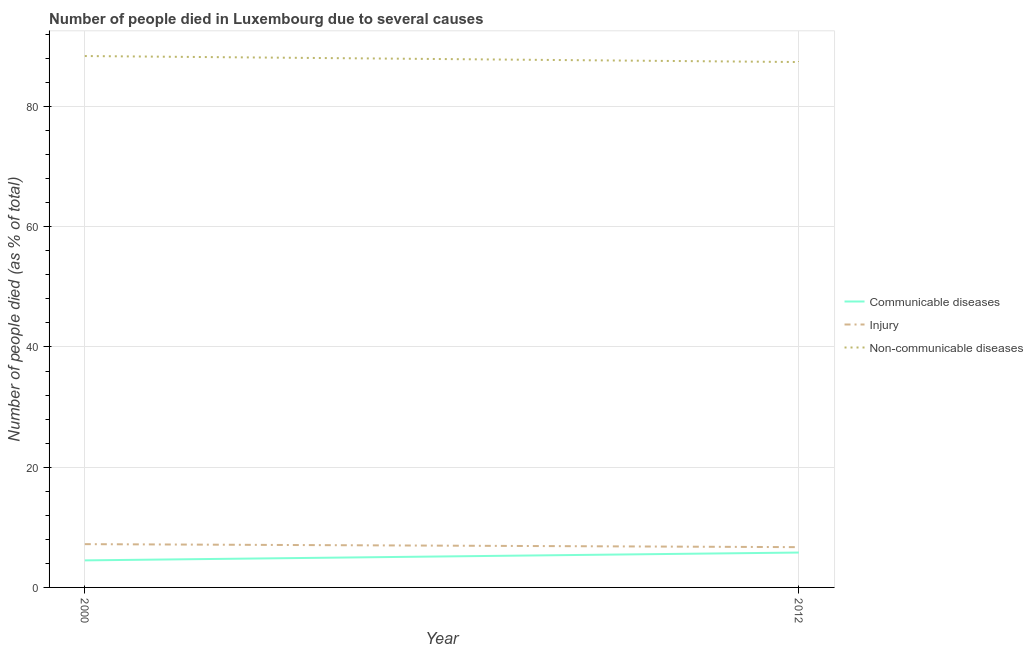Does the line corresponding to number of people who died of injury intersect with the line corresponding to number of people who dies of non-communicable diseases?
Give a very brief answer. No. What is the number of people who dies of non-communicable diseases in 2012?
Your answer should be compact. 87.4. Across all years, what is the maximum number of people who dies of non-communicable diseases?
Your answer should be very brief. 88.4. In which year was the number of people who died of injury minimum?
Ensure brevity in your answer.  2012. What is the total number of people who dies of non-communicable diseases in the graph?
Ensure brevity in your answer.  175.8. What is the difference between the number of people who died of communicable diseases in 2000 and that in 2012?
Your response must be concise. -1.3. What is the difference between the number of people who died of communicable diseases in 2012 and the number of people who dies of non-communicable diseases in 2000?
Give a very brief answer. -82.6. What is the average number of people who dies of non-communicable diseases per year?
Your response must be concise. 87.9. In the year 2000, what is the difference between the number of people who dies of non-communicable diseases and number of people who died of injury?
Keep it short and to the point. 81.2. In how many years, is the number of people who died of communicable diseases greater than 80 %?
Ensure brevity in your answer.  0. What is the ratio of the number of people who dies of non-communicable diseases in 2000 to that in 2012?
Your response must be concise. 1.01. Is the number of people who died of injury in 2000 less than that in 2012?
Make the answer very short. No. Is it the case that in every year, the sum of the number of people who died of communicable diseases and number of people who died of injury is greater than the number of people who dies of non-communicable diseases?
Give a very brief answer. No. Does the number of people who dies of non-communicable diseases monotonically increase over the years?
Your response must be concise. No. Is the number of people who dies of non-communicable diseases strictly greater than the number of people who died of injury over the years?
Make the answer very short. Yes. How many lines are there?
Keep it short and to the point. 3. Where does the legend appear in the graph?
Provide a succinct answer. Center right. How many legend labels are there?
Offer a very short reply. 3. How are the legend labels stacked?
Your answer should be compact. Vertical. What is the title of the graph?
Your answer should be very brief. Number of people died in Luxembourg due to several causes. What is the label or title of the Y-axis?
Offer a very short reply. Number of people died (as % of total). What is the Number of people died (as % of total) in Non-communicable diseases in 2000?
Offer a terse response. 88.4. What is the Number of people died (as % of total) of Injury in 2012?
Make the answer very short. 6.7. What is the Number of people died (as % of total) in Non-communicable diseases in 2012?
Offer a terse response. 87.4. Across all years, what is the maximum Number of people died (as % of total) in Injury?
Provide a short and direct response. 7.2. Across all years, what is the maximum Number of people died (as % of total) in Non-communicable diseases?
Offer a terse response. 88.4. Across all years, what is the minimum Number of people died (as % of total) of Injury?
Give a very brief answer. 6.7. Across all years, what is the minimum Number of people died (as % of total) of Non-communicable diseases?
Ensure brevity in your answer.  87.4. What is the total Number of people died (as % of total) of Communicable diseases in the graph?
Make the answer very short. 10.3. What is the total Number of people died (as % of total) of Non-communicable diseases in the graph?
Offer a terse response. 175.8. What is the difference between the Number of people died (as % of total) of Communicable diseases in 2000 and that in 2012?
Give a very brief answer. -1.3. What is the difference between the Number of people died (as % of total) of Communicable diseases in 2000 and the Number of people died (as % of total) of Injury in 2012?
Your response must be concise. -2.2. What is the difference between the Number of people died (as % of total) of Communicable diseases in 2000 and the Number of people died (as % of total) of Non-communicable diseases in 2012?
Keep it short and to the point. -82.9. What is the difference between the Number of people died (as % of total) of Injury in 2000 and the Number of people died (as % of total) of Non-communicable diseases in 2012?
Ensure brevity in your answer.  -80.2. What is the average Number of people died (as % of total) of Communicable diseases per year?
Provide a succinct answer. 5.15. What is the average Number of people died (as % of total) in Injury per year?
Keep it short and to the point. 6.95. What is the average Number of people died (as % of total) of Non-communicable diseases per year?
Your answer should be very brief. 87.9. In the year 2000, what is the difference between the Number of people died (as % of total) of Communicable diseases and Number of people died (as % of total) of Injury?
Offer a very short reply. -2.7. In the year 2000, what is the difference between the Number of people died (as % of total) of Communicable diseases and Number of people died (as % of total) of Non-communicable diseases?
Give a very brief answer. -83.9. In the year 2000, what is the difference between the Number of people died (as % of total) in Injury and Number of people died (as % of total) in Non-communicable diseases?
Keep it short and to the point. -81.2. In the year 2012, what is the difference between the Number of people died (as % of total) in Communicable diseases and Number of people died (as % of total) in Injury?
Offer a very short reply. -0.9. In the year 2012, what is the difference between the Number of people died (as % of total) in Communicable diseases and Number of people died (as % of total) in Non-communicable diseases?
Your response must be concise. -81.6. In the year 2012, what is the difference between the Number of people died (as % of total) of Injury and Number of people died (as % of total) of Non-communicable diseases?
Keep it short and to the point. -80.7. What is the ratio of the Number of people died (as % of total) in Communicable diseases in 2000 to that in 2012?
Your response must be concise. 0.78. What is the ratio of the Number of people died (as % of total) in Injury in 2000 to that in 2012?
Give a very brief answer. 1.07. What is the ratio of the Number of people died (as % of total) of Non-communicable diseases in 2000 to that in 2012?
Provide a succinct answer. 1.01. What is the difference between the highest and the lowest Number of people died (as % of total) of Communicable diseases?
Your response must be concise. 1.3. 